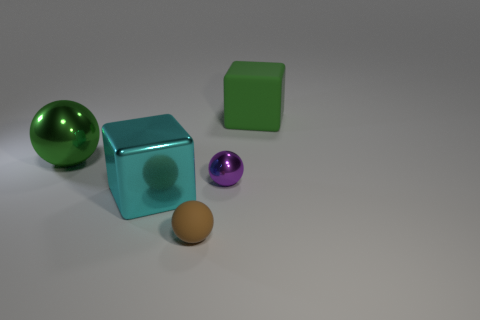Is the number of large green matte cubes less than the number of tiny red metallic cylinders?
Provide a short and direct response. No. What number of objects are either small green objects or green matte blocks?
Give a very brief answer. 1. Does the large green rubber thing have the same shape as the tiny brown matte object?
Your response must be concise. No. Is there anything else that is made of the same material as the tiny purple object?
Keep it short and to the point. Yes. Do the green matte thing that is behind the tiny brown rubber object and the cube in front of the big shiny sphere have the same size?
Provide a succinct answer. Yes. What material is the ball that is to the left of the purple metal thing and in front of the big sphere?
Offer a very short reply. Rubber. Is there anything else that is the same color as the small rubber object?
Your response must be concise. No. Are there fewer large green balls on the right side of the tiny metallic sphere than big yellow rubber spheres?
Provide a short and direct response. No. Is the number of green blocks greater than the number of small brown shiny things?
Offer a very short reply. Yes. There is a small object in front of the large cyan metal block that is in front of the tiny purple metallic sphere; are there any brown rubber balls that are behind it?
Offer a very short reply. No. 